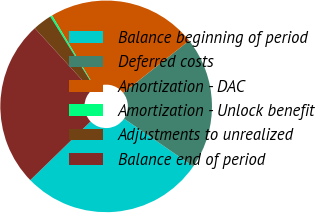Convert chart. <chart><loc_0><loc_0><loc_500><loc_500><pie_chart><fcel>Balance beginning of period<fcel>Deferred costs<fcel>Amortization - DAC<fcel>Amortization - Unlock benefit<fcel>Adjustments to unrealized<fcel>Balance end of period<nl><fcel>28.12%<fcel>20.27%<fcel>22.88%<fcel>0.31%<fcel>2.92%<fcel>25.5%<nl></chart> 